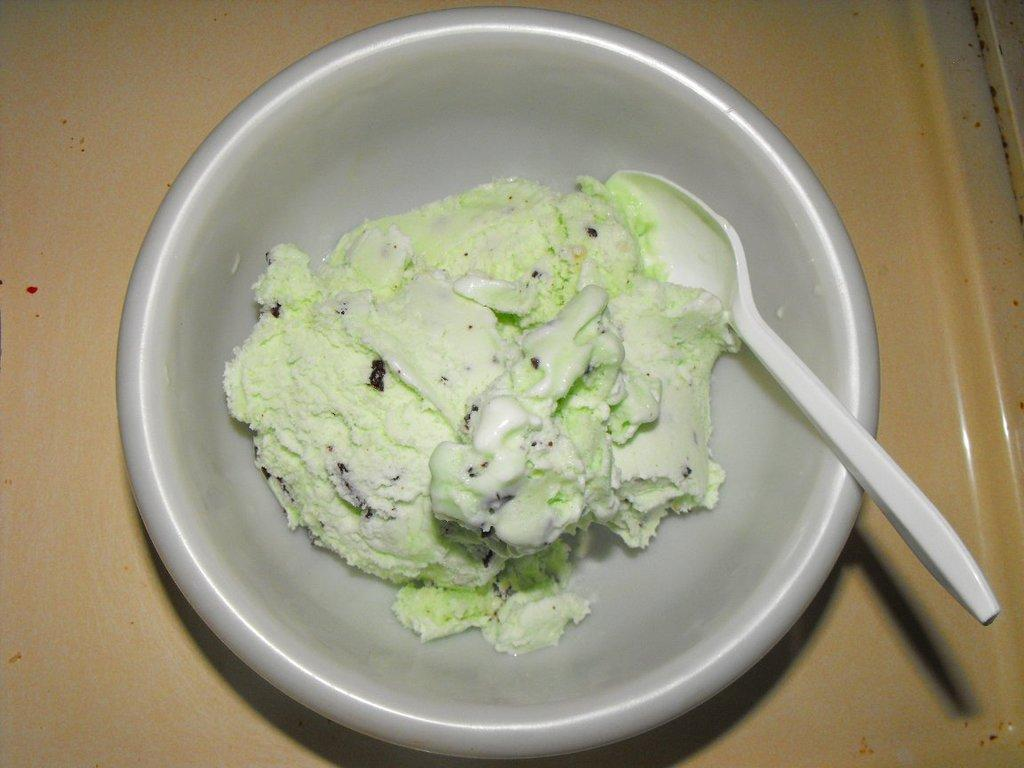What is in the bowl that is visible in the image? There is food in the bowl in the image. What utensil is present in the image? There is a spoon in the image. Where are the bowl and spoon located? The bowl and spoon are on a table in the image. How many patches can be seen on the spoon in the image? There are no patches visible on the spoon in the image, as it is a smooth utensil. 